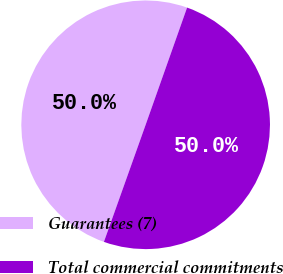<chart> <loc_0><loc_0><loc_500><loc_500><pie_chart><fcel>Guarantees (7)<fcel>Total commercial commitments<nl><fcel>49.96%<fcel>50.04%<nl></chart> 